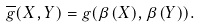Convert formula to latex. <formula><loc_0><loc_0><loc_500><loc_500>\overline { g } ( X , Y ) = g ( \beta ( X ) , \beta ( Y ) ) .</formula> 